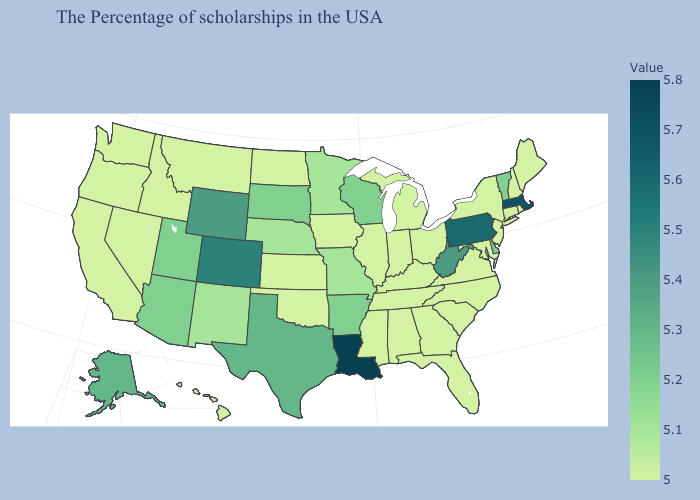Does Colorado have the highest value in the West?
Answer briefly. Yes. Does Pennsylvania have a higher value than Nevada?
Answer briefly. Yes. Among the states that border Iowa , which have the lowest value?
Quick response, please. Illinois. Among the states that border Illinois , which have the highest value?
Short answer required. Wisconsin. Does Wisconsin have the highest value in the USA?
Be succinct. No. 